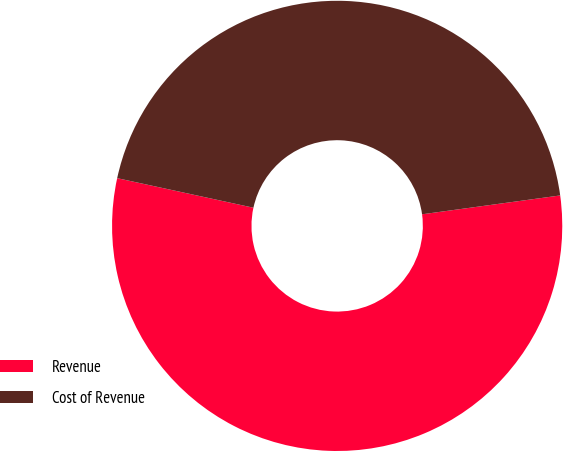Convert chart to OTSL. <chart><loc_0><loc_0><loc_500><loc_500><pie_chart><fcel>Revenue<fcel>Cost of Revenue<nl><fcel>55.56%<fcel>44.44%<nl></chart> 